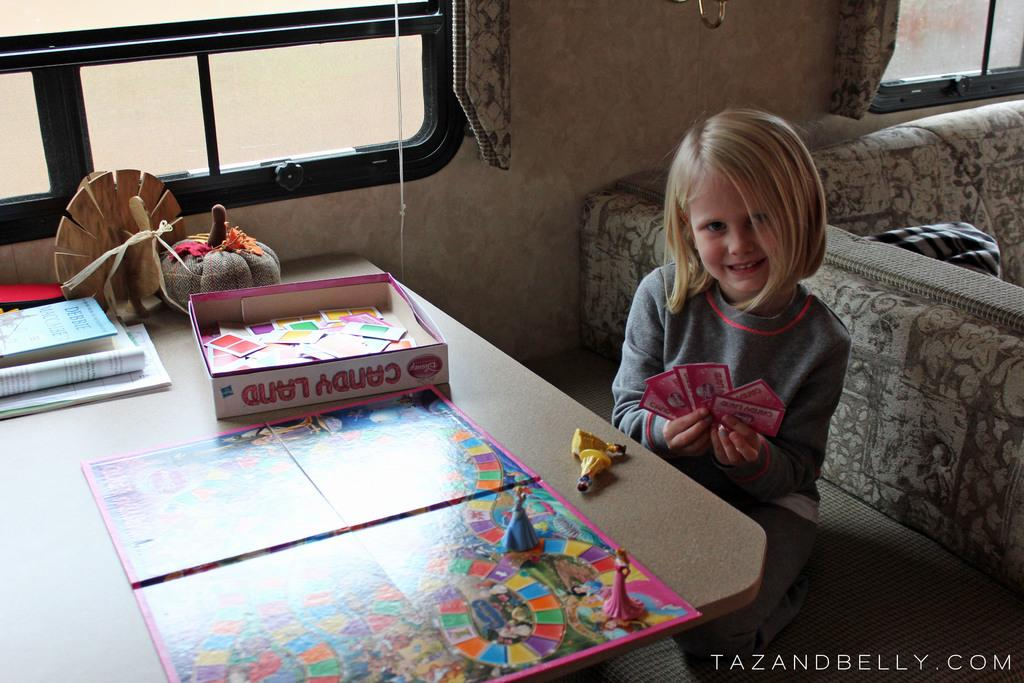<image>
Write a terse but informative summary of the picture. A little girl is sitting at a table and playing the game candy land. 